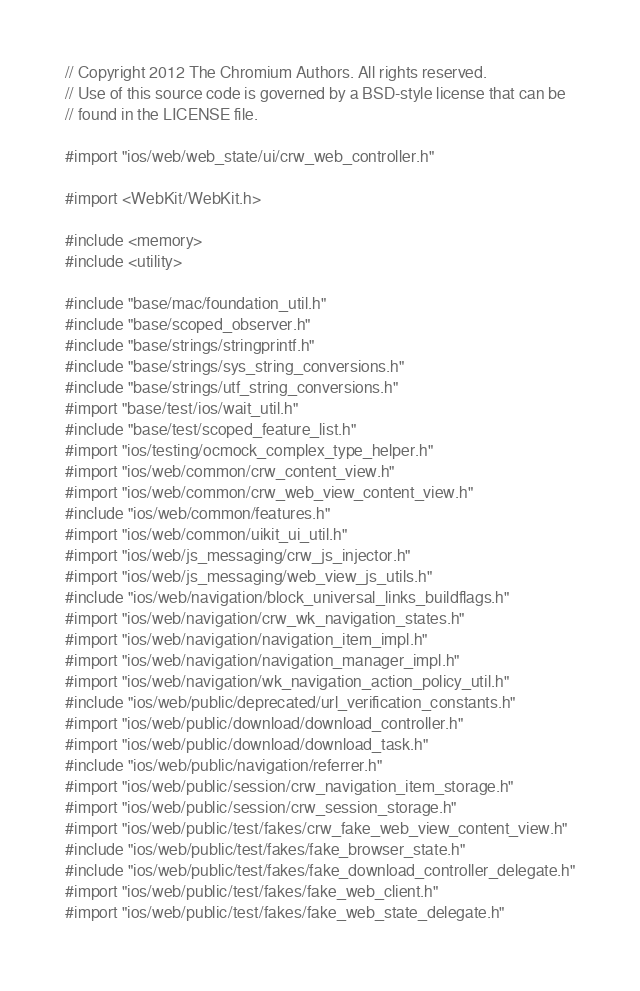Convert code to text. <code><loc_0><loc_0><loc_500><loc_500><_ObjectiveC_>// Copyright 2012 The Chromium Authors. All rights reserved.
// Use of this source code is governed by a BSD-style license that can be
// found in the LICENSE file.

#import "ios/web/web_state/ui/crw_web_controller.h"

#import <WebKit/WebKit.h>

#include <memory>
#include <utility>

#include "base/mac/foundation_util.h"
#include "base/scoped_observer.h"
#include "base/strings/stringprintf.h"
#include "base/strings/sys_string_conversions.h"
#include "base/strings/utf_string_conversions.h"
#import "base/test/ios/wait_util.h"
#include "base/test/scoped_feature_list.h"
#import "ios/testing/ocmock_complex_type_helper.h"
#import "ios/web/common/crw_content_view.h"
#import "ios/web/common/crw_web_view_content_view.h"
#include "ios/web/common/features.h"
#import "ios/web/common/uikit_ui_util.h"
#import "ios/web/js_messaging/crw_js_injector.h"
#import "ios/web/js_messaging/web_view_js_utils.h"
#include "ios/web/navigation/block_universal_links_buildflags.h"
#import "ios/web/navigation/crw_wk_navigation_states.h"
#import "ios/web/navigation/navigation_item_impl.h"
#import "ios/web/navigation/navigation_manager_impl.h"
#import "ios/web/navigation/wk_navigation_action_policy_util.h"
#include "ios/web/public/deprecated/url_verification_constants.h"
#import "ios/web/public/download/download_controller.h"
#import "ios/web/public/download/download_task.h"
#include "ios/web/public/navigation/referrer.h"
#import "ios/web/public/session/crw_navigation_item_storage.h"
#import "ios/web/public/session/crw_session_storage.h"
#import "ios/web/public/test/fakes/crw_fake_web_view_content_view.h"
#include "ios/web/public/test/fakes/fake_browser_state.h"
#include "ios/web/public/test/fakes/fake_download_controller_delegate.h"
#import "ios/web/public/test/fakes/fake_web_client.h"
#import "ios/web/public/test/fakes/fake_web_state_delegate.h"</code> 